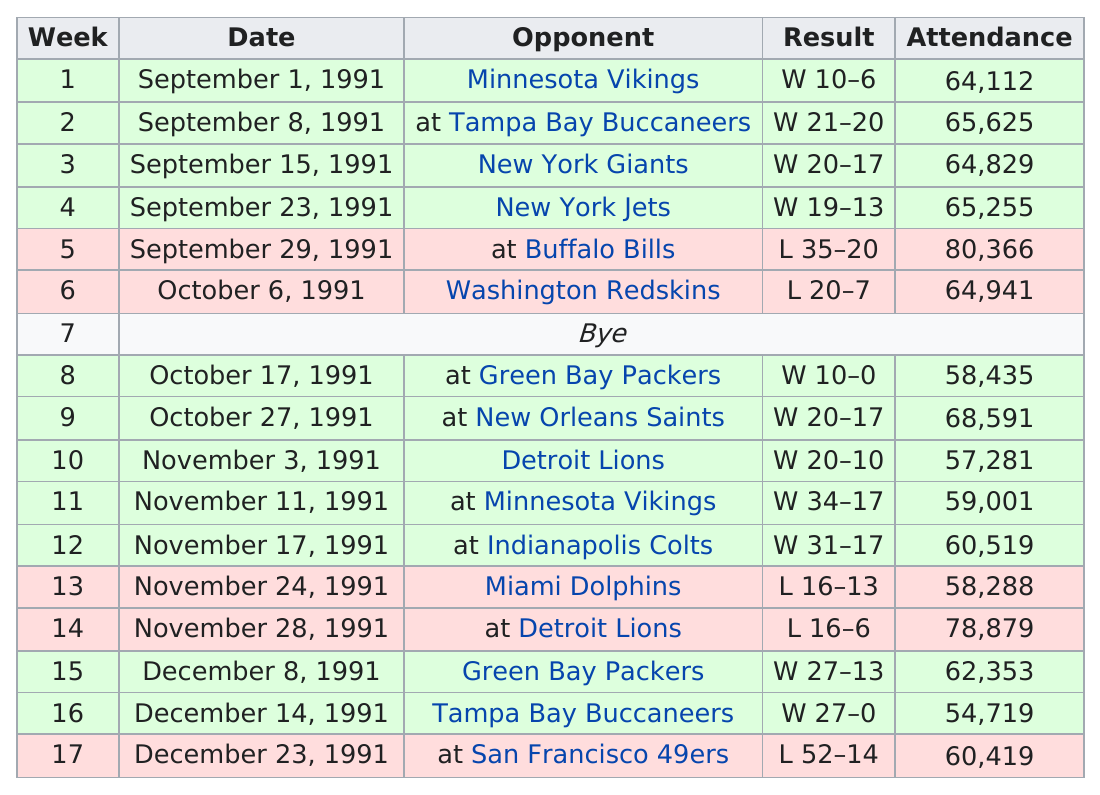List a handful of essential elements in this visual. The New York Jets have the opponent with the highest attendance record for their home games. The game that had the least attendance was played on December 14, 1991. The following opponent faced by the Detroit Lions was the Minnesota Vikings. On December 14, 1991, the Chicago Bears won by a difference of 27 points. What is the week with the highest attendance, and it is 80,000 or more? 